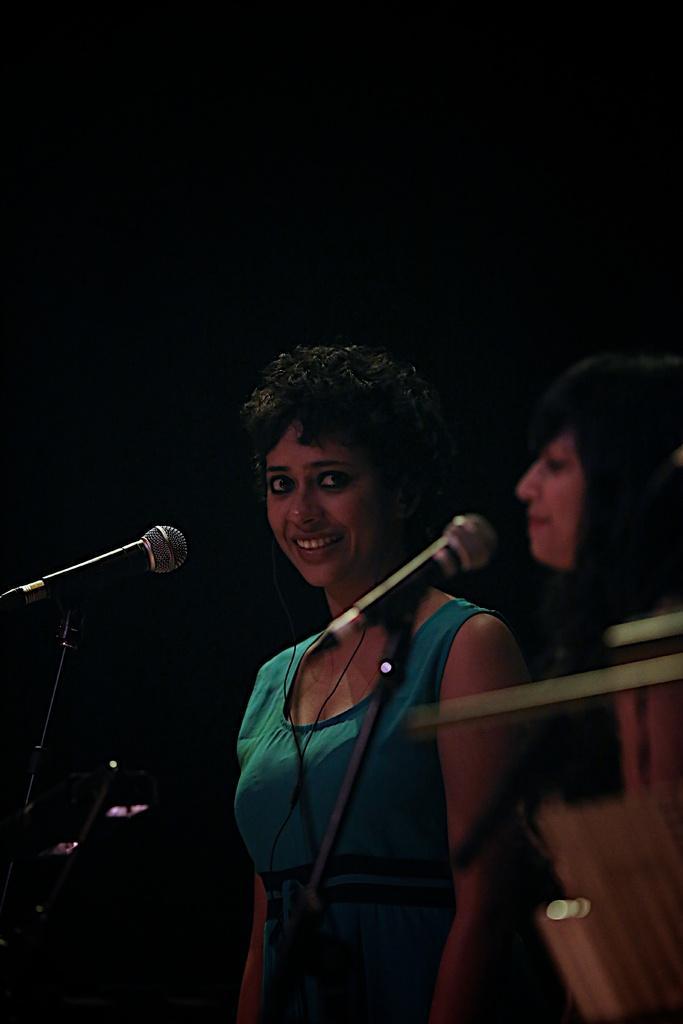How would you summarize this image in a sentence or two? There are two ladies on the right. There are mics in front of them. The lady wearing blue t-shirt is smiling. 